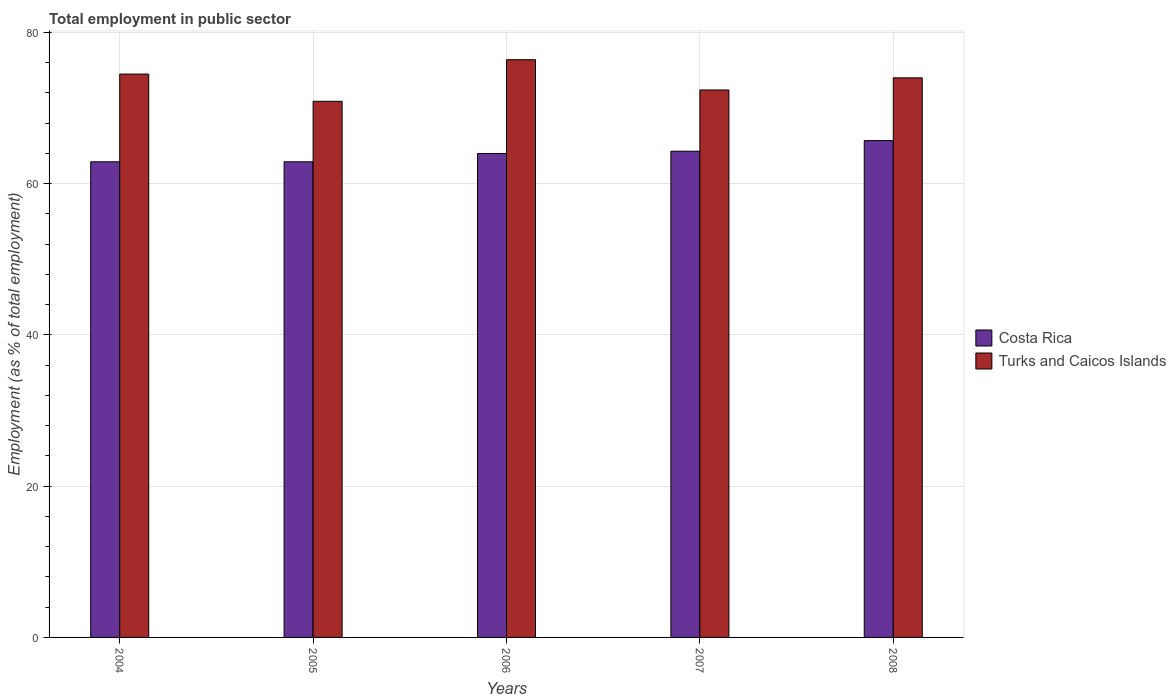How many different coloured bars are there?
Give a very brief answer. 2. Are the number of bars on each tick of the X-axis equal?
Offer a terse response. Yes. What is the label of the 2nd group of bars from the left?
Offer a very short reply. 2005. What is the employment in public sector in Turks and Caicos Islands in 2004?
Give a very brief answer. 74.5. Across all years, what is the maximum employment in public sector in Costa Rica?
Offer a very short reply. 65.7. Across all years, what is the minimum employment in public sector in Costa Rica?
Your answer should be compact. 62.9. In which year was the employment in public sector in Turks and Caicos Islands maximum?
Ensure brevity in your answer.  2006. What is the total employment in public sector in Turks and Caicos Islands in the graph?
Make the answer very short. 368.2. What is the difference between the employment in public sector in Turks and Caicos Islands in 2006 and the employment in public sector in Costa Rica in 2004?
Offer a very short reply. 13.5. What is the average employment in public sector in Costa Rica per year?
Give a very brief answer. 63.96. In the year 2004, what is the difference between the employment in public sector in Turks and Caicos Islands and employment in public sector in Costa Rica?
Your answer should be compact. 11.6. In how many years, is the employment in public sector in Costa Rica greater than 4 %?
Provide a succinct answer. 5. What is the ratio of the employment in public sector in Costa Rica in 2004 to that in 2006?
Keep it short and to the point. 0.98. Is the difference between the employment in public sector in Turks and Caicos Islands in 2005 and 2008 greater than the difference between the employment in public sector in Costa Rica in 2005 and 2008?
Your response must be concise. No. What is the difference between the highest and the second highest employment in public sector in Costa Rica?
Make the answer very short. 1.4. What is the difference between the highest and the lowest employment in public sector in Turks and Caicos Islands?
Provide a succinct answer. 5.5. What does the 1st bar from the right in 2008 represents?
Make the answer very short. Turks and Caicos Islands. How many bars are there?
Your answer should be very brief. 10. What is the difference between two consecutive major ticks on the Y-axis?
Provide a succinct answer. 20. Does the graph contain grids?
Ensure brevity in your answer.  Yes. Where does the legend appear in the graph?
Make the answer very short. Center right. What is the title of the graph?
Provide a succinct answer. Total employment in public sector. What is the label or title of the X-axis?
Make the answer very short. Years. What is the label or title of the Y-axis?
Make the answer very short. Employment (as % of total employment). What is the Employment (as % of total employment) in Costa Rica in 2004?
Make the answer very short. 62.9. What is the Employment (as % of total employment) of Turks and Caicos Islands in 2004?
Keep it short and to the point. 74.5. What is the Employment (as % of total employment) in Costa Rica in 2005?
Keep it short and to the point. 62.9. What is the Employment (as % of total employment) of Turks and Caicos Islands in 2005?
Your answer should be very brief. 70.9. What is the Employment (as % of total employment) in Turks and Caicos Islands in 2006?
Ensure brevity in your answer.  76.4. What is the Employment (as % of total employment) in Costa Rica in 2007?
Offer a very short reply. 64.3. What is the Employment (as % of total employment) in Turks and Caicos Islands in 2007?
Provide a succinct answer. 72.4. What is the Employment (as % of total employment) in Costa Rica in 2008?
Make the answer very short. 65.7. Across all years, what is the maximum Employment (as % of total employment) of Costa Rica?
Give a very brief answer. 65.7. Across all years, what is the maximum Employment (as % of total employment) in Turks and Caicos Islands?
Your response must be concise. 76.4. Across all years, what is the minimum Employment (as % of total employment) in Costa Rica?
Make the answer very short. 62.9. Across all years, what is the minimum Employment (as % of total employment) of Turks and Caicos Islands?
Your answer should be very brief. 70.9. What is the total Employment (as % of total employment) in Costa Rica in the graph?
Offer a very short reply. 319.8. What is the total Employment (as % of total employment) in Turks and Caicos Islands in the graph?
Your answer should be very brief. 368.2. What is the difference between the Employment (as % of total employment) in Costa Rica in 2004 and that in 2005?
Provide a succinct answer. 0. What is the difference between the Employment (as % of total employment) in Turks and Caicos Islands in 2004 and that in 2005?
Provide a short and direct response. 3.6. What is the difference between the Employment (as % of total employment) of Costa Rica in 2004 and that in 2006?
Offer a very short reply. -1.1. What is the difference between the Employment (as % of total employment) in Turks and Caicos Islands in 2004 and that in 2006?
Your answer should be compact. -1.9. What is the difference between the Employment (as % of total employment) of Turks and Caicos Islands in 2004 and that in 2008?
Offer a very short reply. 0.5. What is the difference between the Employment (as % of total employment) in Costa Rica in 2005 and that in 2006?
Make the answer very short. -1.1. What is the difference between the Employment (as % of total employment) of Turks and Caicos Islands in 2005 and that in 2006?
Provide a succinct answer. -5.5. What is the difference between the Employment (as % of total employment) in Costa Rica in 2005 and that in 2007?
Offer a very short reply. -1.4. What is the difference between the Employment (as % of total employment) in Costa Rica in 2006 and that in 2007?
Offer a very short reply. -0.3. What is the difference between the Employment (as % of total employment) of Turks and Caicos Islands in 2006 and that in 2007?
Make the answer very short. 4. What is the difference between the Employment (as % of total employment) of Costa Rica in 2006 and that in 2008?
Your answer should be compact. -1.7. What is the difference between the Employment (as % of total employment) in Turks and Caicos Islands in 2006 and that in 2008?
Provide a short and direct response. 2.4. What is the difference between the Employment (as % of total employment) in Costa Rica in 2007 and that in 2008?
Offer a very short reply. -1.4. What is the difference between the Employment (as % of total employment) of Costa Rica in 2004 and the Employment (as % of total employment) of Turks and Caicos Islands in 2007?
Ensure brevity in your answer.  -9.5. What is the difference between the Employment (as % of total employment) of Costa Rica in 2005 and the Employment (as % of total employment) of Turks and Caicos Islands in 2007?
Your answer should be very brief. -9.5. What is the difference between the Employment (as % of total employment) of Costa Rica in 2005 and the Employment (as % of total employment) of Turks and Caicos Islands in 2008?
Ensure brevity in your answer.  -11.1. What is the difference between the Employment (as % of total employment) in Costa Rica in 2007 and the Employment (as % of total employment) in Turks and Caicos Islands in 2008?
Your answer should be compact. -9.7. What is the average Employment (as % of total employment) in Costa Rica per year?
Your answer should be compact. 63.96. What is the average Employment (as % of total employment) in Turks and Caicos Islands per year?
Offer a very short reply. 73.64. In the year 2004, what is the difference between the Employment (as % of total employment) in Costa Rica and Employment (as % of total employment) in Turks and Caicos Islands?
Provide a short and direct response. -11.6. In the year 2006, what is the difference between the Employment (as % of total employment) of Costa Rica and Employment (as % of total employment) of Turks and Caicos Islands?
Offer a very short reply. -12.4. In the year 2007, what is the difference between the Employment (as % of total employment) in Costa Rica and Employment (as % of total employment) in Turks and Caicos Islands?
Offer a very short reply. -8.1. What is the ratio of the Employment (as % of total employment) in Costa Rica in 2004 to that in 2005?
Offer a terse response. 1. What is the ratio of the Employment (as % of total employment) in Turks and Caicos Islands in 2004 to that in 2005?
Give a very brief answer. 1.05. What is the ratio of the Employment (as % of total employment) of Costa Rica in 2004 to that in 2006?
Make the answer very short. 0.98. What is the ratio of the Employment (as % of total employment) of Turks and Caicos Islands in 2004 to that in 2006?
Make the answer very short. 0.98. What is the ratio of the Employment (as % of total employment) of Costa Rica in 2004 to that in 2007?
Your answer should be very brief. 0.98. What is the ratio of the Employment (as % of total employment) of Costa Rica in 2004 to that in 2008?
Give a very brief answer. 0.96. What is the ratio of the Employment (as % of total employment) of Turks and Caicos Islands in 2004 to that in 2008?
Make the answer very short. 1.01. What is the ratio of the Employment (as % of total employment) of Costa Rica in 2005 to that in 2006?
Your answer should be compact. 0.98. What is the ratio of the Employment (as % of total employment) in Turks and Caicos Islands in 2005 to that in 2006?
Give a very brief answer. 0.93. What is the ratio of the Employment (as % of total employment) of Costa Rica in 2005 to that in 2007?
Your answer should be very brief. 0.98. What is the ratio of the Employment (as % of total employment) of Turks and Caicos Islands in 2005 to that in 2007?
Provide a succinct answer. 0.98. What is the ratio of the Employment (as % of total employment) in Costa Rica in 2005 to that in 2008?
Make the answer very short. 0.96. What is the ratio of the Employment (as % of total employment) of Turks and Caicos Islands in 2005 to that in 2008?
Offer a very short reply. 0.96. What is the ratio of the Employment (as % of total employment) of Turks and Caicos Islands in 2006 to that in 2007?
Ensure brevity in your answer.  1.06. What is the ratio of the Employment (as % of total employment) of Costa Rica in 2006 to that in 2008?
Provide a succinct answer. 0.97. What is the ratio of the Employment (as % of total employment) of Turks and Caicos Islands in 2006 to that in 2008?
Your response must be concise. 1.03. What is the ratio of the Employment (as % of total employment) in Costa Rica in 2007 to that in 2008?
Your answer should be very brief. 0.98. What is the ratio of the Employment (as % of total employment) of Turks and Caicos Islands in 2007 to that in 2008?
Your answer should be compact. 0.98. What is the difference between the highest and the second highest Employment (as % of total employment) in Turks and Caicos Islands?
Your answer should be very brief. 1.9. What is the difference between the highest and the lowest Employment (as % of total employment) in Turks and Caicos Islands?
Your answer should be very brief. 5.5. 